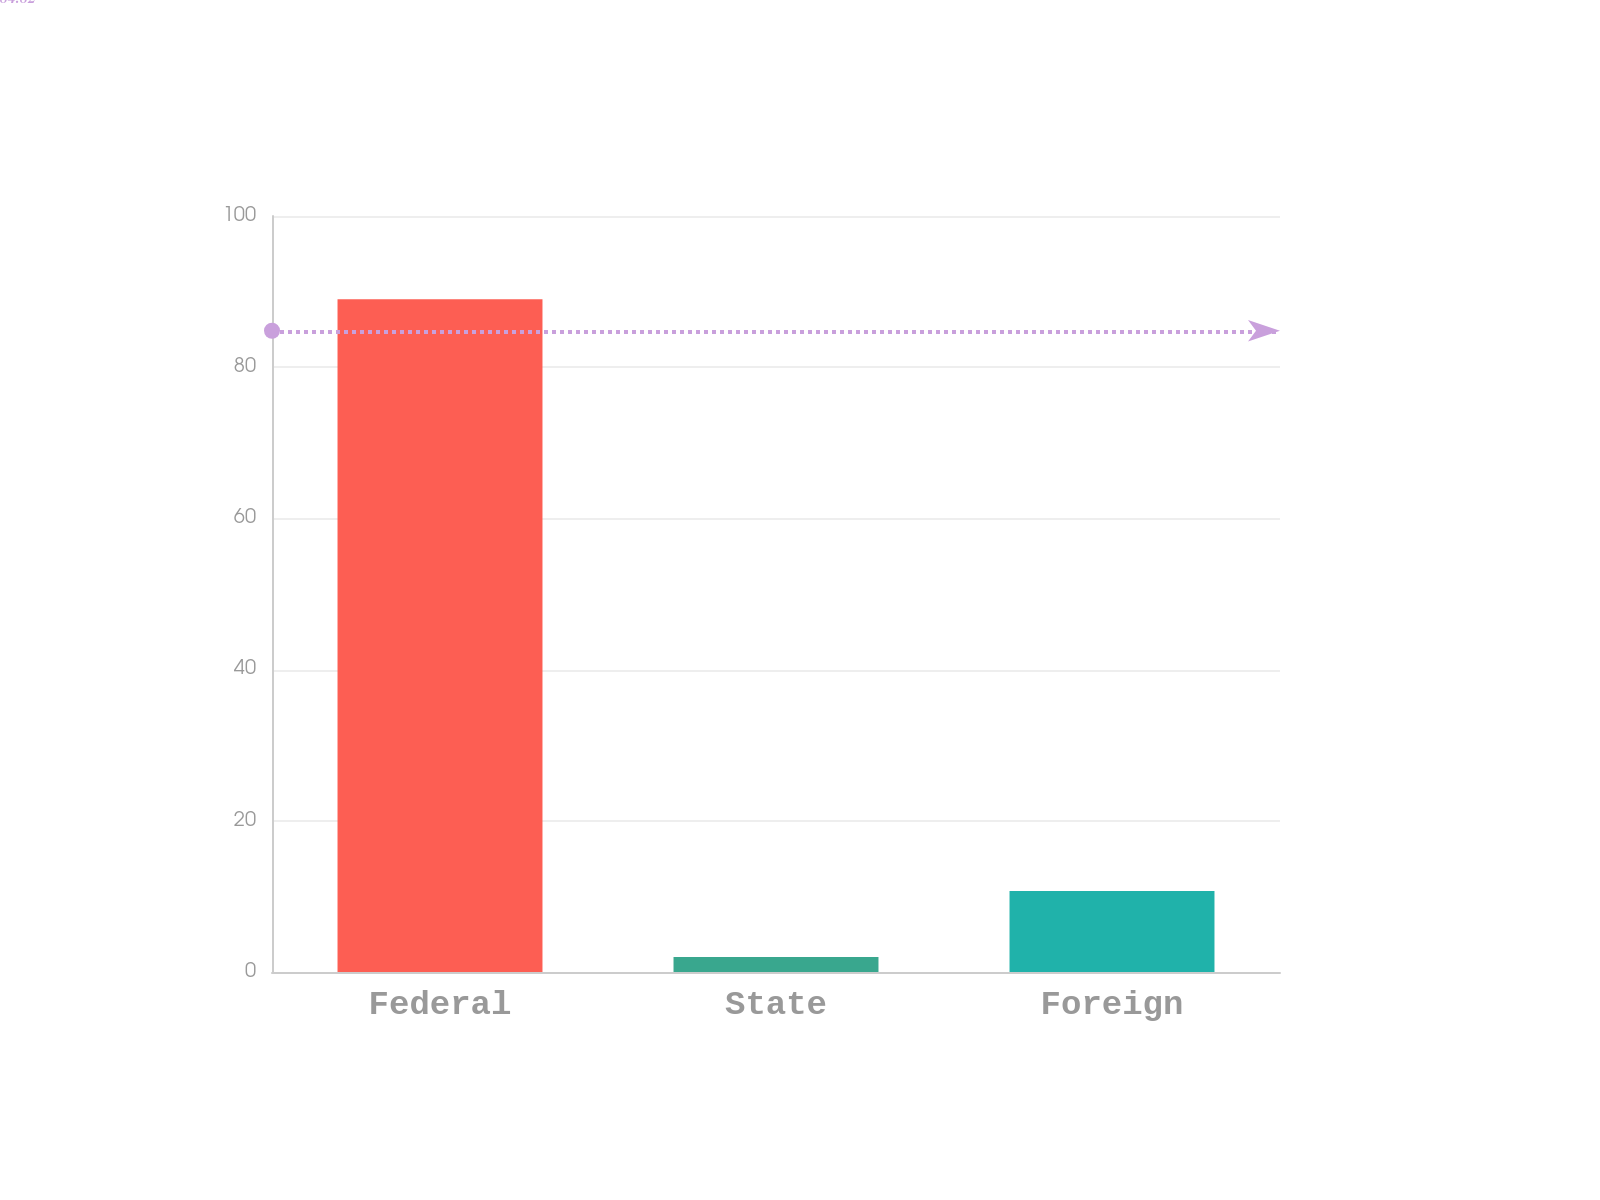Convert chart to OTSL. <chart><loc_0><loc_0><loc_500><loc_500><bar_chart><fcel>Federal<fcel>State<fcel>Foreign<nl><fcel>89<fcel>2<fcel>10.7<nl></chart> 